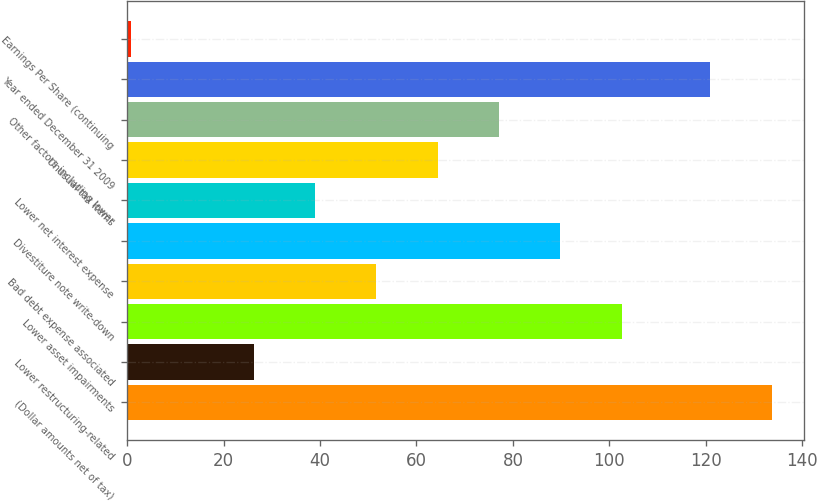Convert chart. <chart><loc_0><loc_0><loc_500><loc_500><bar_chart><fcel>(Dollar amounts net of tax)<fcel>Lower restructuring-related<fcel>Lower asset impairments<fcel>Bad debt expense associated<fcel>Divestiture note write-down<fcel>Lower net interest expense<fcel>Unusual tax items<fcel>Other factors including lower<fcel>Year ended December 31 2009<fcel>Earnings Per Share (continuing<nl><fcel>133.73<fcel>26.19<fcel>102.57<fcel>51.65<fcel>89.84<fcel>38.92<fcel>64.38<fcel>77.11<fcel>121<fcel>0.73<nl></chart> 